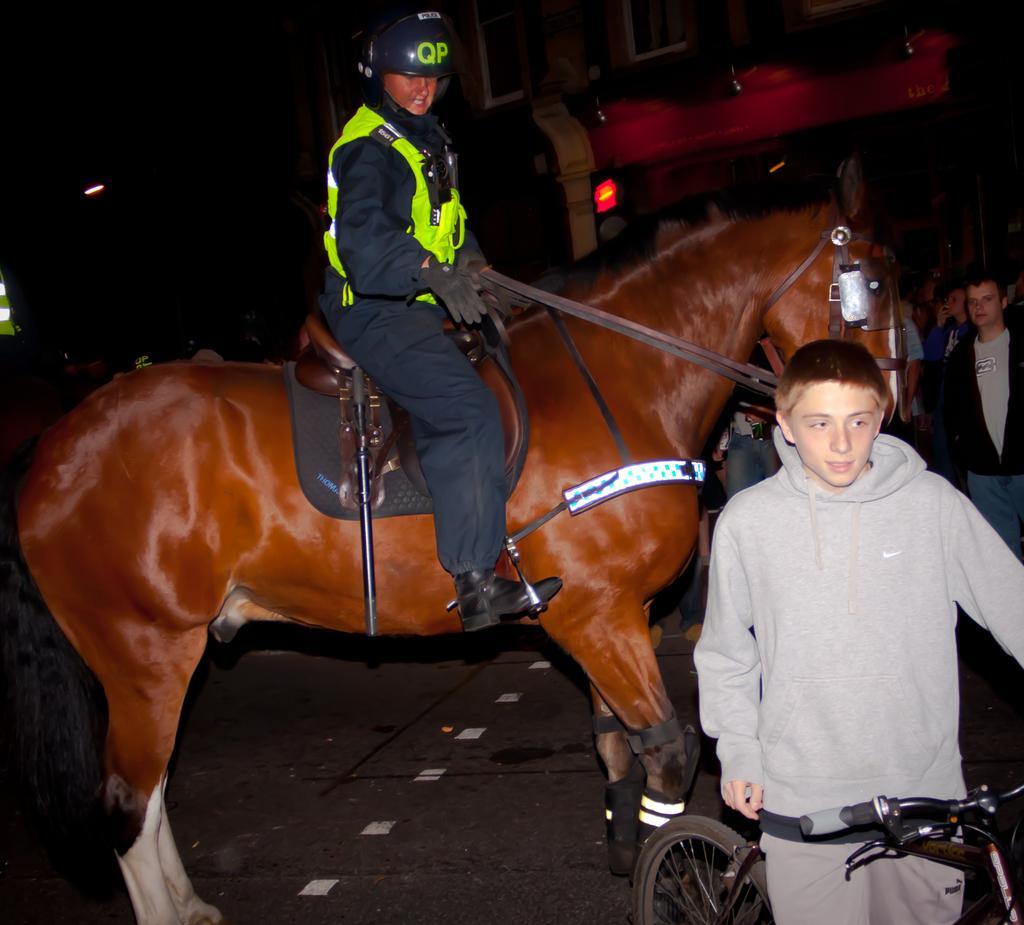Please provide a concise description of this image. In this picture we can see a man who is sitting on the horse. This is road and there is a man on the bicycle. Here we can see few people are standing on the road. On the background there is a building. And this is the light. 